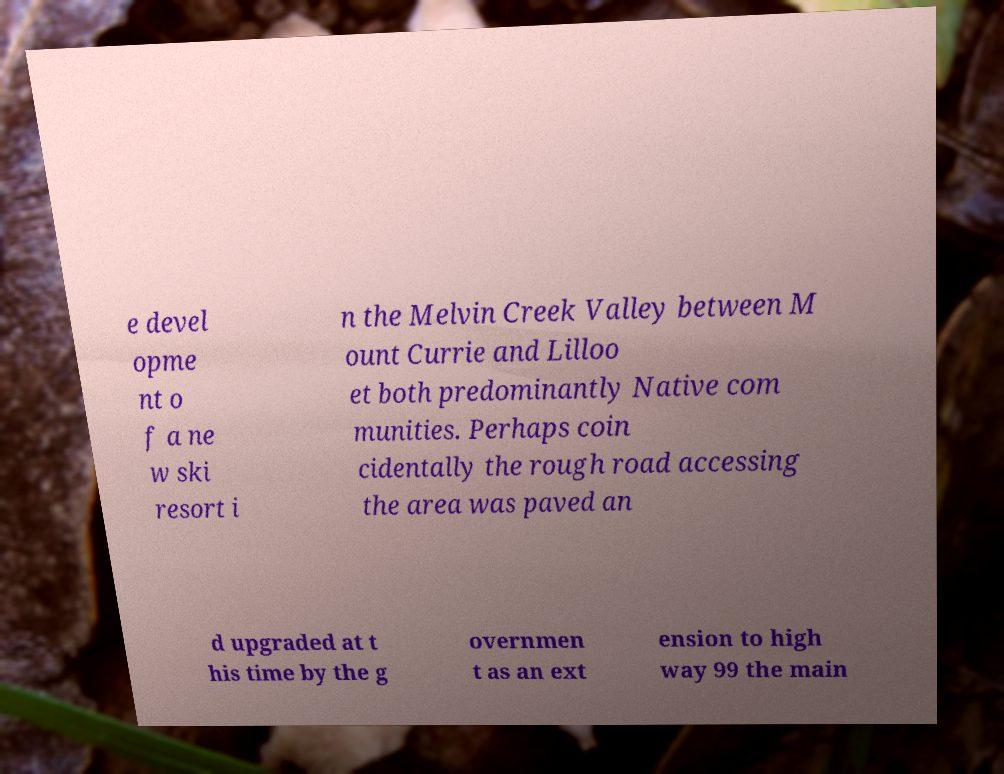Could you assist in decoding the text presented in this image and type it out clearly? e devel opme nt o f a ne w ski resort i n the Melvin Creek Valley between M ount Currie and Lilloo et both predominantly Native com munities. Perhaps coin cidentally the rough road accessing the area was paved an d upgraded at t his time by the g overnmen t as an ext ension to high way 99 the main 